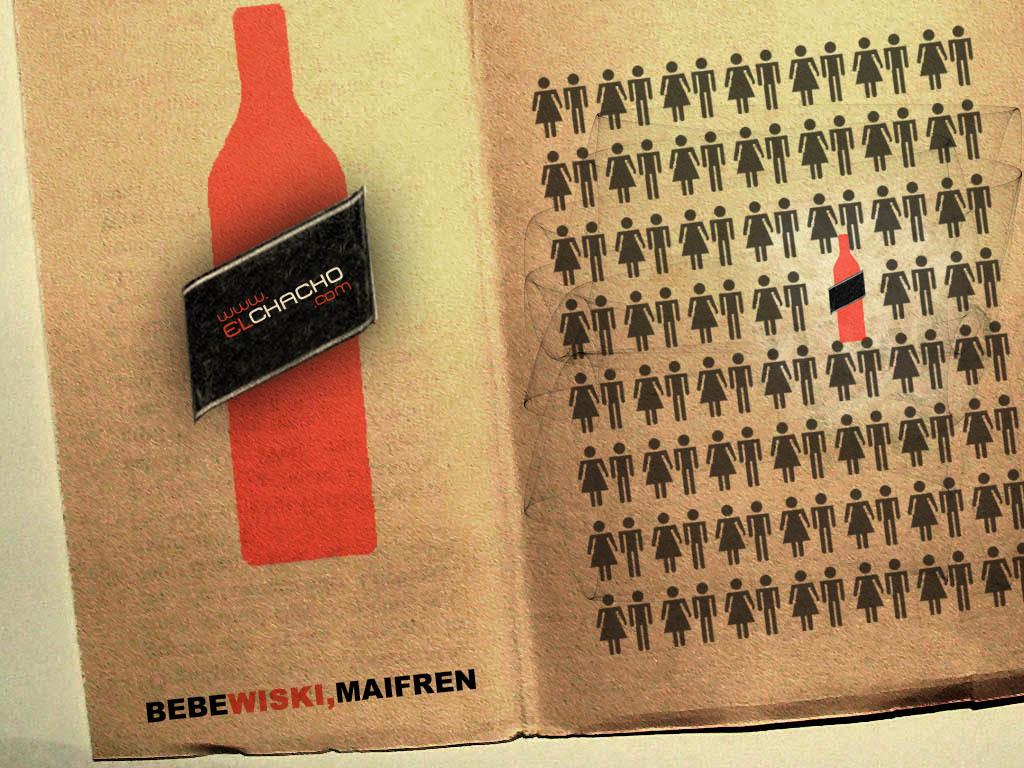<image>
Provide a brief description of the given image. An open book, the words Bebe and Maifren are visible in black text. 